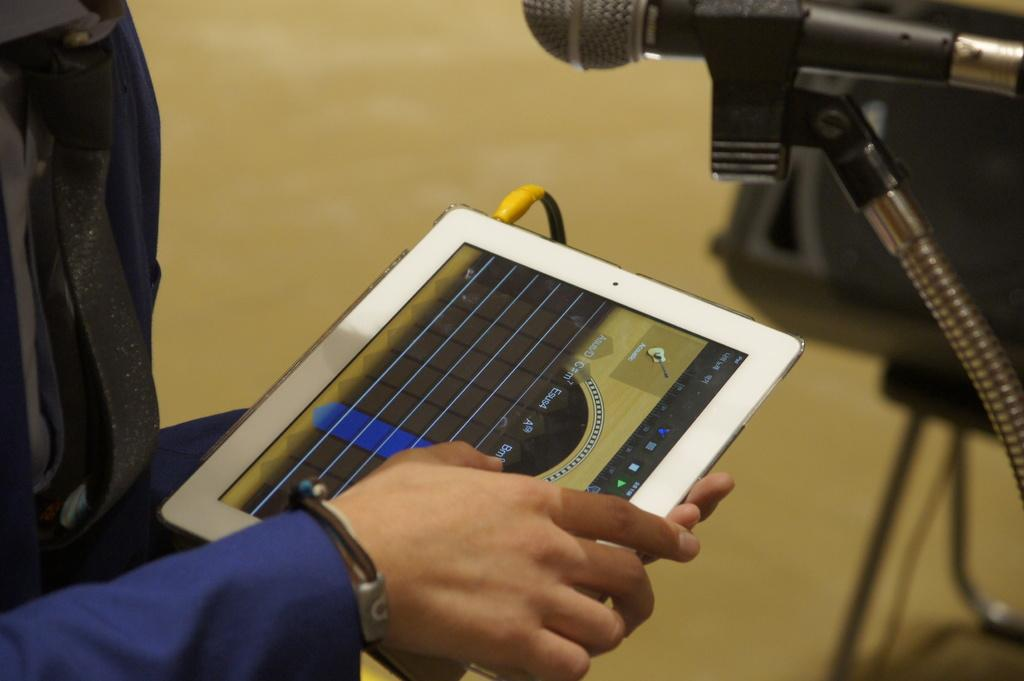What is the main subject of the image? There is a person in the image. What is the person holding in the image? The person is holding a tab. What can be seen on the right side of the image? There is a microphone on the right side of the image. Is there any connection between the microphone and the person? Yes, there is a wire associated with the microphone. How would you describe the background of the image? The background of the image is blurry. What type of paper is the person using to slip while driving in the image? There is no paper, slipping, or driving present in the image. 